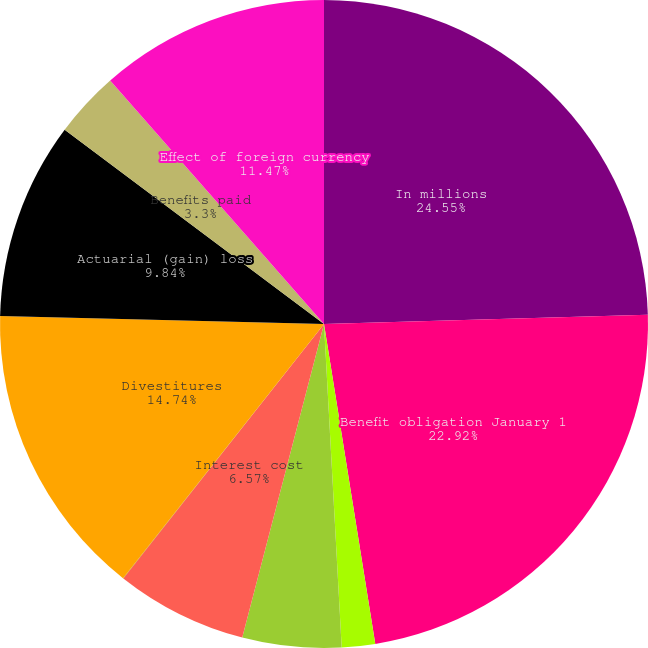Convert chart. <chart><loc_0><loc_0><loc_500><loc_500><pie_chart><fcel>In millions<fcel>Benefit obligation January 1<fcel>Obligations for additional<fcel>Service cost<fcel>Interest cost<fcel>Participants' contributions<fcel>Divestitures<fcel>Actuarial (gain) loss<fcel>Benefits paid<fcel>Effect of foreign currency<nl><fcel>24.55%<fcel>22.92%<fcel>1.66%<fcel>4.93%<fcel>6.57%<fcel>0.02%<fcel>14.74%<fcel>9.84%<fcel>3.3%<fcel>11.47%<nl></chart> 